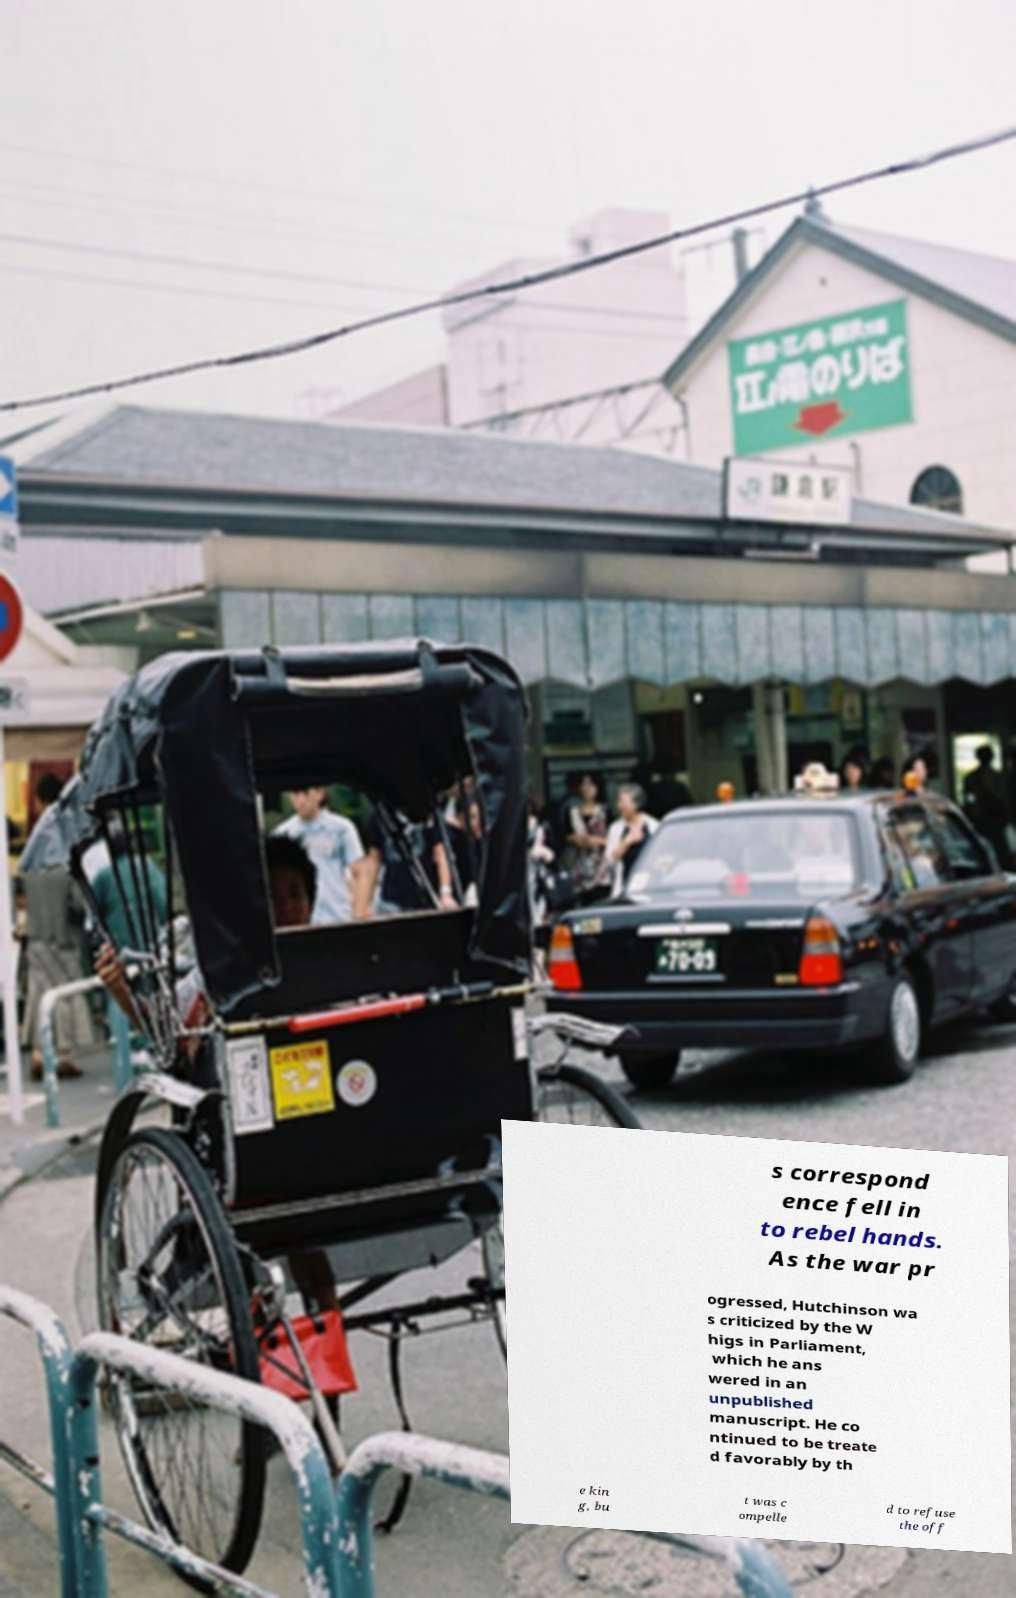There's text embedded in this image that I need extracted. Can you transcribe it verbatim? s correspond ence fell in to rebel hands. As the war pr ogressed, Hutchinson wa s criticized by the W higs in Parliament, which he ans wered in an unpublished manuscript. He co ntinued to be treate d favorably by th e kin g, bu t was c ompelle d to refuse the off 